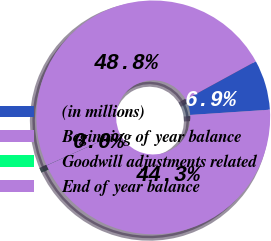Convert chart to OTSL. <chart><loc_0><loc_0><loc_500><loc_500><pie_chart><fcel>(in millions)<fcel>Beginning of year balance<fcel>Goodwill adjustments related<fcel>End of year balance<nl><fcel>6.91%<fcel>44.31%<fcel>0.01%<fcel>48.77%<nl></chart> 